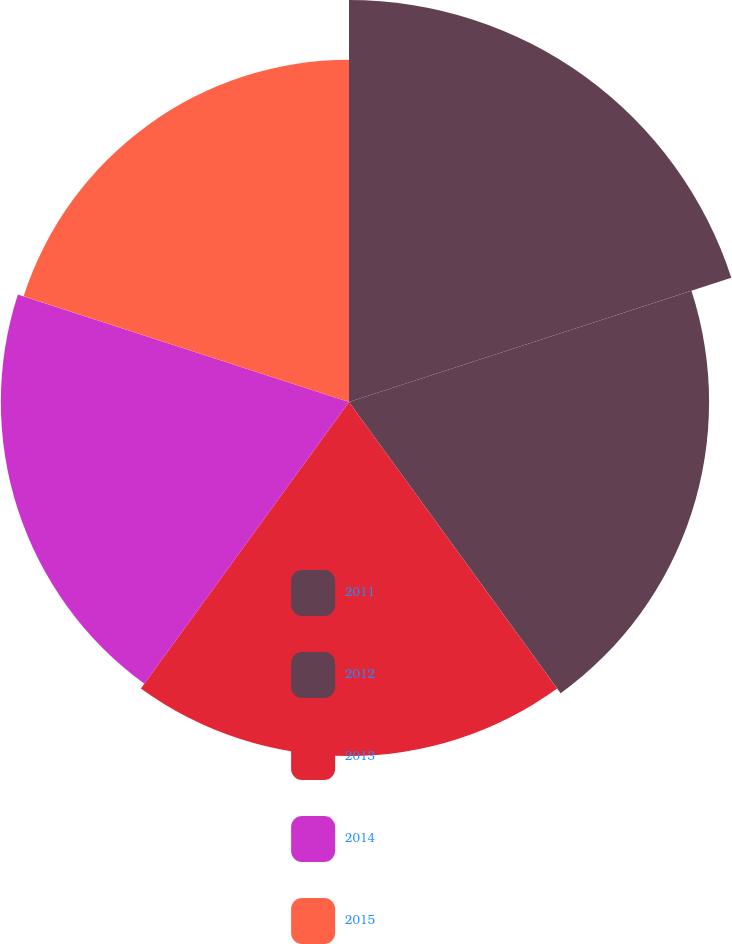<chart> <loc_0><loc_0><loc_500><loc_500><pie_chart><fcel>2011<fcel>2012<fcel>2013<fcel>2014<fcel>2015<nl><fcel>22.25%<fcel>19.93%<fcel>19.6%<fcel>19.27%<fcel>18.94%<nl></chart> 